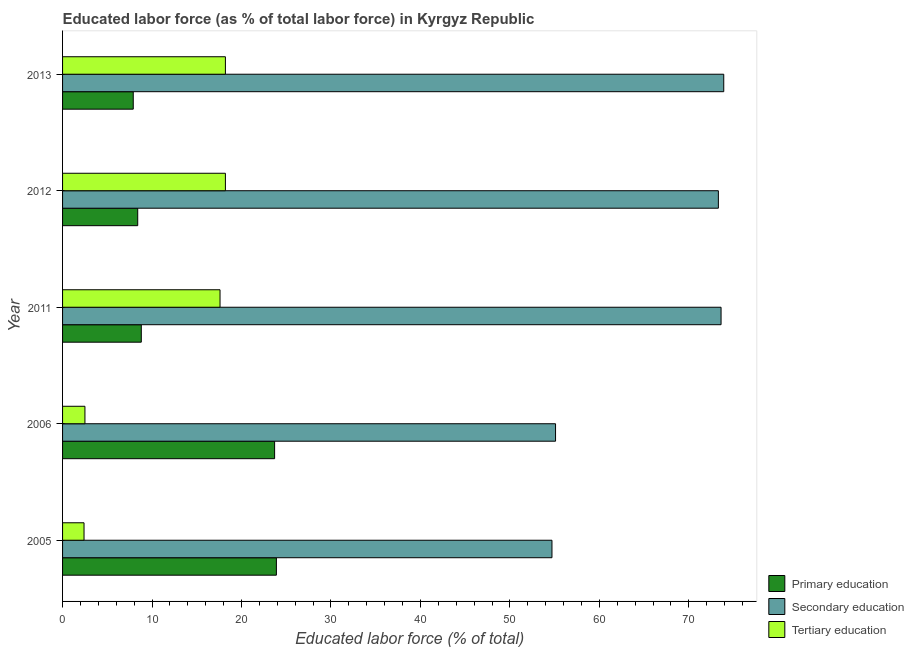How many groups of bars are there?
Provide a succinct answer. 5. Are the number of bars per tick equal to the number of legend labels?
Provide a short and direct response. Yes. Are the number of bars on each tick of the Y-axis equal?
Provide a succinct answer. Yes. How many bars are there on the 1st tick from the top?
Offer a terse response. 3. How many bars are there on the 4th tick from the bottom?
Provide a short and direct response. 3. What is the label of the 4th group of bars from the top?
Your answer should be compact. 2006. In how many cases, is the number of bars for a given year not equal to the number of legend labels?
Your answer should be compact. 0. What is the percentage of labor force who received primary education in 2011?
Provide a succinct answer. 8.8. Across all years, what is the maximum percentage of labor force who received primary education?
Your response must be concise. 23.9. Across all years, what is the minimum percentage of labor force who received primary education?
Give a very brief answer. 7.9. In which year was the percentage of labor force who received secondary education minimum?
Make the answer very short. 2005. What is the total percentage of labor force who received primary education in the graph?
Provide a short and direct response. 72.7. What is the difference between the percentage of labor force who received tertiary education in 2006 and that in 2013?
Provide a succinct answer. -15.7. What is the difference between the percentage of labor force who received tertiary education in 2006 and the percentage of labor force who received secondary education in 2005?
Offer a terse response. -52.2. What is the average percentage of labor force who received tertiary education per year?
Offer a very short reply. 11.78. In the year 2006, what is the difference between the percentage of labor force who received primary education and percentage of labor force who received tertiary education?
Give a very brief answer. 21.2. In how many years, is the percentage of labor force who received secondary education greater than 62 %?
Offer a terse response. 3. What is the ratio of the percentage of labor force who received primary education in 2005 to that in 2013?
Provide a succinct answer. 3.02. Is the difference between the percentage of labor force who received tertiary education in 2011 and 2012 greater than the difference between the percentage of labor force who received secondary education in 2011 and 2012?
Keep it short and to the point. No. What is the difference between the highest and the lowest percentage of labor force who received primary education?
Provide a succinct answer. 16. What does the 2nd bar from the top in 2013 represents?
Offer a very short reply. Secondary education. What does the 2nd bar from the bottom in 2005 represents?
Offer a very short reply. Secondary education. How many bars are there?
Provide a short and direct response. 15. How many years are there in the graph?
Your response must be concise. 5. What is the difference between two consecutive major ticks on the X-axis?
Give a very brief answer. 10. Does the graph contain grids?
Your answer should be compact. No. How many legend labels are there?
Ensure brevity in your answer.  3. How are the legend labels stacked?
Your answer should be compact. Vertical. What is the title of the graph?
Keep it short and to the point. Educated labor force (as % of total labor force) in Kyrgyz Republic. What is the label or title of the X-axis?
Give a very brief answer. Educated labor force (% of total). What is the Educated labor force (% of total) in Primary education in 2005?
Your answer should be compact. 23.9. What is the Educated labor force (% of total) of Secondary education in 2005?
Give a very brief answer. 54.7. What is the Educated labor force (% of total) in Tertiary education in 2005?
Offer a terse response. 2.4. What is the Educated labor force (% of total) of Primary education in 2006?
Provide a succinct answer. 23.7. What is the Educated labor force (% of total) in Secondary education in 2006?
Give a very brief answer. 55.1. What is the Educated labor force (% of total) in Primary education in 2011?
Provide a short and direct response. 8.8. What is the Educated labor force (% of total) in Secondary education in 2011?
Your answer should be compact. 73.6. What is the Educated labor force (% of total) in Tertiary education in 2011?
Your answer should be very brief. 17.6. What is the Educated labor force (% of total) in Primary education in 2012?
Your answer should be compact. 8.4. What is the Educated labor force (% of total) of Secondary education in 2012?
Your answer should be compact. 73.3. What is the Educated labor force (% of total) of Tertiary education in 2012?
Your response must be concise. 18.2. What is the Educated labor force (% of total) in Primary education in 2013?
Your answer should be compact. 7.9. What is the Educated labor force (% of total) of Secondary education in 2013?
Ensure brevity in your answer.  73.9. What is the Educated labor force (% of total) in Tertiary education in 2013?
Make the answer very short. 18.2. Across all years, what is the maximum Educated labor force (% of total) in Primary education?
Provide a short and direct response. 23.9. Across all years, what is the maximum Educated labor force (% of total) of Secondary education?
Your answer should be compact. 73.9. Across all years, what is the maximum Educated labor force (% of total) in Tertiary education?
Keep it short and to the point. 18.2. Across all years, what is the minimum Educated labor force (% of total) in Primary education?
Make the answer very short. 7.9. Across all years, what is the minimum Educated labor force (% of total) in Secondary education?
Make the answer very short. 54.7. Across all years, what is the minimum Educated labor force (% of total) in Tertiary education?
Provide a short and direct response. 2.4. What is the total Educated labor force (% of total) in Primary education in the graph?
Provide a short and direct response. 72.7. What is the total Educated labor force (% of total) in Secondary education in the graph?
Your answer should be very brief. 330.6. What is the total Educated labor force (% of total) of Tertiary education in the graph?
Make the answer very short. 58.9. What is the difference between the Educated labor force (% of total) of Primary education in 2005 and that in 2011?
Provide a succinct answer. 15.1. What is the difference between the Educated labor force (% of total) in Secondary education in 2005 and that in 2011?
Keep it short and to the point. -18.9. What is the difference between the Educated labor force (% of total) in Tertiary education in 2005 and that in 2011?
Your response must be concise. -15.2. What is the difference between the Educated labor force (% of total) of Primary education in 2005 and that in 2012?
Your answer should be compact. 15.5. What is the difference between the Educated labor force (% of total) in Secondary education in 2005 and that in 2012?
Your response must be concise. -18.6. What is the difference between the Educated labor force (% of total) of Tertiary education in 2005 and that in 2012?
Your response must be concise. -15.8. What is the difference between the Educated labor force (% of total) of Primary education in 2005 and that in 2013?
Provide a short and direct response. 16. What is the difference between the Educated labor force (% of total) in Secondary education in 2005 and that in 2013?
Ensure brevity in your answer.  -19.2. What is the difference between the Educated labor force (% of total) of Tertiary education in 2005 and that in 2013?
Make the answer very short. -15.8. What is the difference between the Educated labor force (% of total) in Secondary education in 2006 and that in 2011?
Offer a terse response. -18.5. What is the difference between the Educated labor force (% of total) of Tertiary education in 2006 and that in 2011?
Your response must be concise. -15.1. What is the difference between the Educated labor force (% of total) of Secondary education in 2006 and that in 2012?
Offer a terse response. -18.2. What is the difference between the Educated labor force (% of total) in Tertiary education in 2006 and that in 2012?
Provide a succinct answer. -15.7. What is the difference between the Educated labor force (% of total) in Secondary education in 2006 and that in 2013?
Ensure brevity in your answer.  -18.8. What is the difference between the Educated labor force (% of total) in Tertiary education in 2006 and that in 2013?
Provide a succinct answer. -15.7. What is the difference between the Educated labor force (% of total) of Primary education in 2011 and that in 2013?
Provide a short and direct response. 0.9. What is the difference between the Educated labor force (% of total) of Tertiary education in 2011 and that in 2013?
Provide a short and direct response. -0.6. What is the difference between the Educated labor force (% of total) of Secondary education in 2012 and that in 2013?
Make the answer very short. -0.6. What is the difference between the Educated labor force (% of total) in Primary education in 2005 and the Educated labor force (% of total) in Secondary education in 2006?
Ensure brevity in your answer.  -31.2. What is the difference between the Educated labor force (% of total) of Primary education in 2005 and the Educated labor force (% of total) of Tertiary education in 2006?
Your response must be concise. 21.4. What is the difference between the Educated labor force (% of total) of Secondary education in 2005 and the Educated labor force (% of total) of Tertiary education in 2006?
Offer a very short reply. 52.2. What is the difference between the Educated labor force (% of total) of Primary education in 2005 and the Educated labor force (% of total) of Secondary education in 2011?
Your response must be concise. -49.7. What is the difference between the Educated labor force (% of total) in Primary education in 2005 and the Educated labor force (% of total) in Tertiary education in 2011?
Your response must be concise. 6.3. What is the difference between the Educated labor force (% of total) of Secondary education in 2005 and the Educated labor force (% of total) of Tertiary education in 2011?
Keep it short and to the point. 37.1. What is the difference between the Educated labor force (% of total) in Primary education in 2005 and the Educated labor force (% of total) in Secondary education in 2012?
Your answer should be very brief. -49.4. What is the difference between the Educated labor force (% of total) of Primary education in 2005 and the Educated labor force (% of total) of Tertiary education in 2012?
Give a very brief answer. 5.7. What is the difference between the Educated labor force (% of total) of Secondary education in 2005 and the Educated labor force (% of total) of Tertiary education in 2012?
Make the answer very short. 36.5. What is the difference between the Educated labor force (% of total) of Primary education in 2005 and the Educated labor force (% of total) of Tertiary education in 2013?
Offer a terse response. 5.7. What is the difference between the Educated labor force (% of total) in Secondary education in 2005 and the Educated labor force (% of total) in Tertiary education in 2013?
Give a very brief answer. 36.5. What is the difference between the Educated labor force (% of total) of Primary education in 2006 and the Educated labor force (% of total) of Secondary education in 2011?
Give a very brief answer. -49.9. What is the difference between the Educated labor force (% of total) in Secondary education in 2006 and the Educated labor force (% of total) in Tertiary education in 2011?
Make the answer very short. 37.5. What is the difference between the Educated labor force (% of total) of Primary education in 2006 and the Educated labor force (% of total) of Secondary education in 2012?
Your answer should be compact. -49.6. What is the difference between the Educated labor force (% of total) in Secondary education in 2006 and the Educated labor force (% of total) in Tertiary education in 2012?
Give a very brief answer. 36.9. What is the difference between the Educated labor force (% of total) of Primary education in 2006 and the Educated labor force (% of total) of Secondary education in 2013?
Provide a short and direct response. -50.2. What is the difference between the Educated labor force (% of total) of Secondary education in 2006 and the Educated labor force (% of total) of Tertiary education in 2013?
Ensure brevity in your answer.  36.9. What is the difference between the Educated labor force (% of total) in Primary education in 2011 and the Educated labor force (% of total) in Secondary education in 2012?
Make the answer very short. -64.5. What is the difference between the Educated labor force (% of total) in Primary education in 2011 and the Educated labor force (% of total) in Tertiary education in 2012?
Your answer should be compact. -9.4. What is the difference between the Educated labor force (% of total) in Secondary education in 2011 and the Educated labor force (% of total) in Tertiary education in 2012?
Offer a terse response. 55.4. What is the difference between the Educated labor force (% of total) in Primary education in 2011 and the Educated labor force (% of total) in Secondary education in 2013?
Your response must be concise. -65.1. What is the difference between the Educated labor force (% of total) of Secondary education in 2011 and the Educated labor force (% of total) of Tertiary education in 2013?
Your answer should be compact. 55.4. What is the difference between the Educated labor force (% of total) of Primary education in 2012 and the Educated labor force (% of total) of Secondary education in 2013?
Your answer should be very brief. -65.5. What is the difference between the Educated labor force (% of total) in Primary education in 2012 and the Educated labor force (% of total) in Tertiary education in 2013?
Provide a short and direct response. -9.8. What is the difference between the Educated labor force (% of total) of Secondary education in 2012 and the Educated labor force (% of total) of Tertiary education in 2013?
Ensure brevity in your answer.  55.1. What is the average Educated labor force (% of total) in Primary education per year?
Offer a very short reply. 14.54. What is the average Educated labor force (% of total) in Secondary education per year?
Provide a succinct answer. 66.12. What is the average Educated labor force (% of total) in Tertiary education per year?
Your answer should be compact. 11.78. In the year 2005, what is the difference between the Educated labor force (% of total) in Primary education and Educated labor force (% of total) in Secondary education?
Provide a succinct answer. -30.8. In the year 2005, what is the difference between the Educated labor force (% of total) of Primary education and Educated labor force (% of total) of Tertiary education?
Make the answer very short. 21.5. In the year 2005, what is the difference between the Educated labor force (% of total) of Secondary education and Educated labor force (% of total) of Tertiary education?
Your answer should be compact. 52.3. In the year 2006, what is the difference between the Educated labor force (% of total) in Primary education and Educated labor force (% of total) in Secondary education?
Provide a succinct answer. -31.4. In the year 2006, what is the difference between the Educated labor force (% of total) in Primary education and Educated labor force (% of total) in Tertiary education?
Give a very brief answer. 21.2. In the year 2006, what is the difference between the Educated labor force (% of total) in Secondary education and Educated labor force (% of total) in Tertiary education?
Your response must be concise. 52.6. In the year 2011, what is the difference between the Educated labor force (% of total) of Primary education and Educated labor force (% of total) of Secondary education?
Give a very brief answer. -64.8. In the year 2012, what is the difference between the Educated labor force (% of total) of Primary education and Educated labor force (% of total) of Secondary education?
Keep it short and to the point. -64.9. In the year 2012, what is the difference between the Educated labor force (% of total) of Primary education and Educated labor force (% of total) of Tertiary education?
Your response must be concise. -9.8. In the year 2012, what is the difference between the Educated labor force (% of total) of Secondary education and Educated labor force (% of total) of Tertiary education?
Your answer should be compact. 55.1. In the year 2013, what is the difference between the Educated labor force (% of total) in Primary education and Educated labor force (% of total) in Secondary education?
Keep it short and to the point. -66. In the year 2013, what is the difference between the Educated labor force (% of total) of Secondary education and Educated labor force (% of total) of Tertiary education?
Make the answer very short. 55.7. What is the ratio of the Educated labor force (% of total) in Primary education in 2005 to that in 2006?
Keep it short and to the point. 1.01. What is the ratio of the Educated labor force (% of total) in Secondary education in 2005 to that in 2006?
Your answer should be compact. 0.99. What is the ratio of the Educated labor force (% of total) of Primary education in 2005 to that in 2011?
Your answer should be very brief. 2.72. What is the ratio of the Educated labor force (% of total) of Secondary education in 2005 to that in 2011?
Offer a terse response. 0.74. What is the ratio of the Educated labor force (% of total) in Tertiary education in 2005 to that in 2011?
Offer a very short reply. 0.14. What is the ratio of the Educated labor force (% of total) of Primary education in 2005 to that in 2012?
Offer a terse response. 2.85. What is the ratio of the Educated labor force (% of total) of Secondary education in 2005 to that in 2012?
Your answer should be compact. 0.75. What is the ratio of the Educated labor force (% of total) in Tertiary education in 2005 to that in 2012?
Provide a succinct answer. 0.13. What is the ratio of the Educated labor force (% of total) in Primary education in 2005 to that in 2013?
Ensure brevity in your answer.  3.03. What is the ratio of the Educated labor force (% of total) of Secondary education in 2005 to that in 2013?
Keep it short and to the point. 0.74. What is the ratio of the Educated labor force (% of total) of Tertiary education in 2005 to that in 2013?
Ensure brevity in your answer.  0.13. What is the ratio of the Educated labor force (% of total) in Primary education in 2006 to that in 2011?
Give a very brief answer. 2.69. What is the ratio of the Educated labor force (% of total) in Secondary education in 2006 to that in 2011?
Your response must be concise. 0.75. What is the ratio of the Educated labor force (% of total) of Tertiary education in 2006 to that in 2011?
Your response must be concise. 0.14. What is the ratio of the Educated labor force (% of total) of Primary education in 2006 to that in 2012?
Your answer should be compact. 2.82. What is the ratio of the Educated labor force (% of total) of Secondary education in 2006 to that in 2012?
Provide a short and direct response. 0.75. What is the ratio of the Educated labor force (% of total) of Tertiary education in 2006 to that in 2012?
Make the answer very short. 0.14. What is the ratio of the Educated labor force (% of total) in Secondary education in 2006 to that in 2013?
Make the answer very short. 0.75. What is the ratio of the Educated labor force (% of total) of Tertiary education in 2006 to that in 2013?
Make the answer very short. 0.14. What is the ratio of the Educated labor force (% of total) in Primary education in 2011 to that in 2012?
Your answer should be compact. 1.05. What is the ratio of the Educated labor force (% of total) of Secondary education in 2011 to that in 2012?
Keep it short and to the point. 1. What is the ratio of the Educated labor force (% of total) of Primary education in 2011 to that in 2013?
Make the answer very short. 1.11. What is the ratio of the Educated labor force (% of total) of Secondary education in 2011 to that in 2013?
Your answer should be compact. 1. What is the ratio of the Educated labor force (% of total) in Primary education in 2012 to that in 2013?
Your response must be concise. 1.06. What is the difference between the highest and the second highest Educated labor force (% of total) of Secondary education?
Make the answer very short. 0.3. What is the difference between the highest and the lowest Educated labor force (% of total) of Primary education?
Your answer should be compact. 16. What is the difference between the highest and the lowest Educated labor force (% of total) of Tertiary education?
Provide a succinct answer. 15.8. 